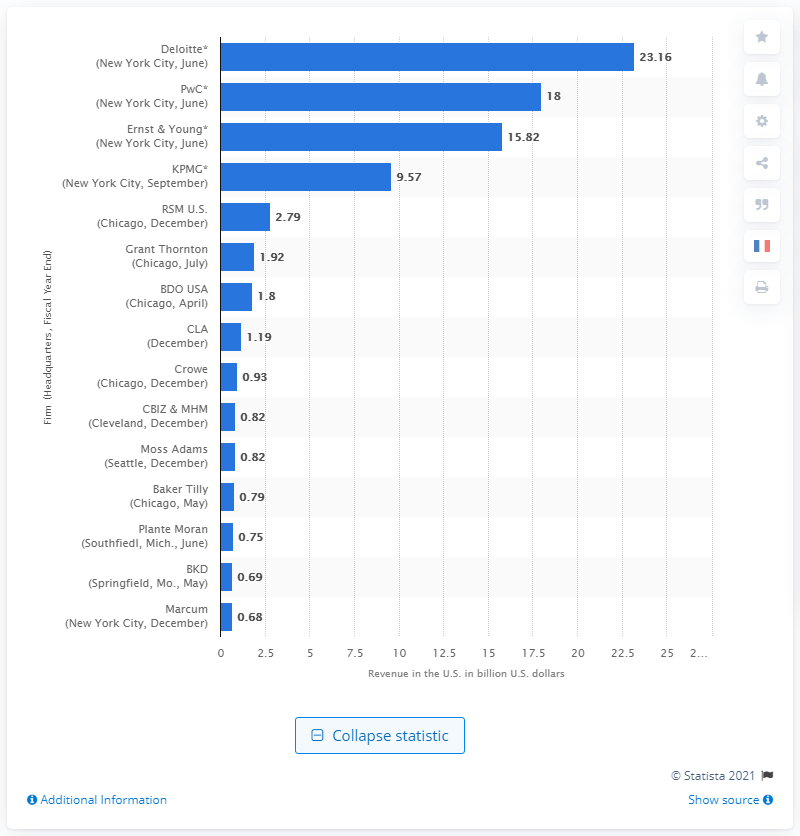Point out several critical features in this image. Deloitte's U.S. revenue in dollars was reported to be 23.16. 